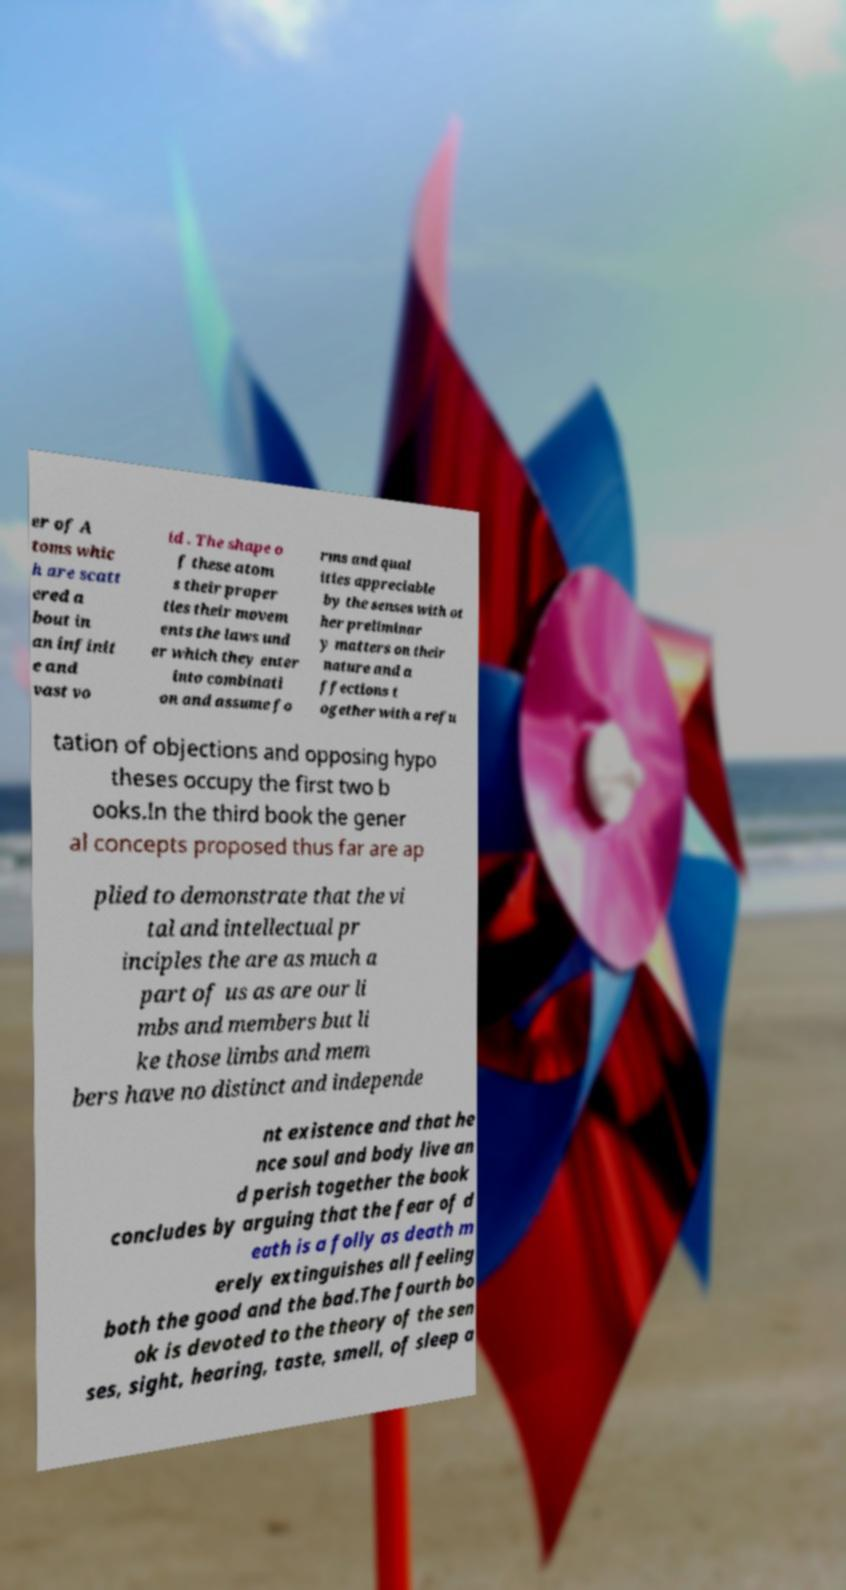There's text embedded in this image that I need extracted. Can you transcribe it verbatim? er of A toms whic h are scatt ered a bout in an infinit e and vast vo id . The shape o f these atom s their proper ties their movem ents the laws und er which they enter into combinati on and assume fo rms and qual ities appreciable by the senses with ot her preliminar y matters on their nature and a ffections t ogether with a refu tation of objections and opposing hypo theses occupy the first two b ooks.In the third book the gener al concepts proposed thus far are ap plied to demonstrate that the vi tal and intellectual pr inciples the are as much a part of us as are our li mbs and members but li ke those limbs and mem bers have no distinct and independe nt existence and that he nce soul and body live an d perish together the book concludes by arguing that the fear of d eath is a folly as death m erely extinguishes all feeling both the good and the bad.The fourth bo ok is devoted to the theory of the sen ses, sight, hearing, taste, smell, of sleep a 